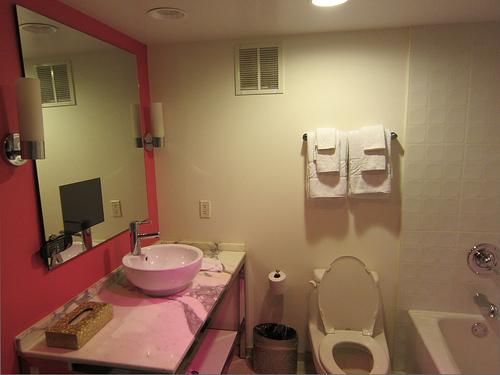What can you say about the bathroom vanity and countertop in the image? The bathroom vanity has a marble countertop. Tell me about the mirror in the bathroom described in the image. There is a large mirror hanging on the bathroom wall. Tell me what the toilet seat's position is and its color. The toilet seat is up and it is white. Find out how many smaller and larger towels are hanging up and their colors. There are two smaller white towels and two larger white towels hanging up. Explain the type of trash can and its position in the image. A brown and black trash can is positioned under the sink. What type of light is on the wall and its color? There are two white and silver lights on the wall. Can you describe the type and color of the towels hanging in the bathroom? There are four white towels hanging on a towel bar in the bathroom. Describe the appearance and position of the tissue box in the image. There is a brown tissue box on the counter top. Identify the color of the wall described in the image. The wall is painted pink. What type of sink and its position is depicted in the image? There is a white bowl sink on the counter top. 